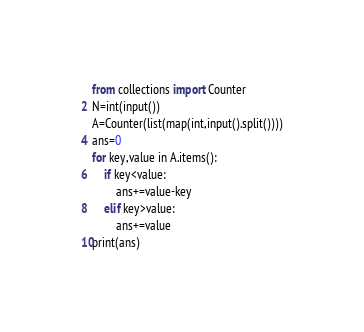<code> <loc_0><loc_0><loc_500><loc_500><_Python_>from collections import Counter
N=int(input())
A=Counter(list(map(int,input().split())))
ans=0
for key,value in A.items():
    if key<value:
        ans+=value-key
    elif key>value:
        ans+=value
print(ans)
</code> 